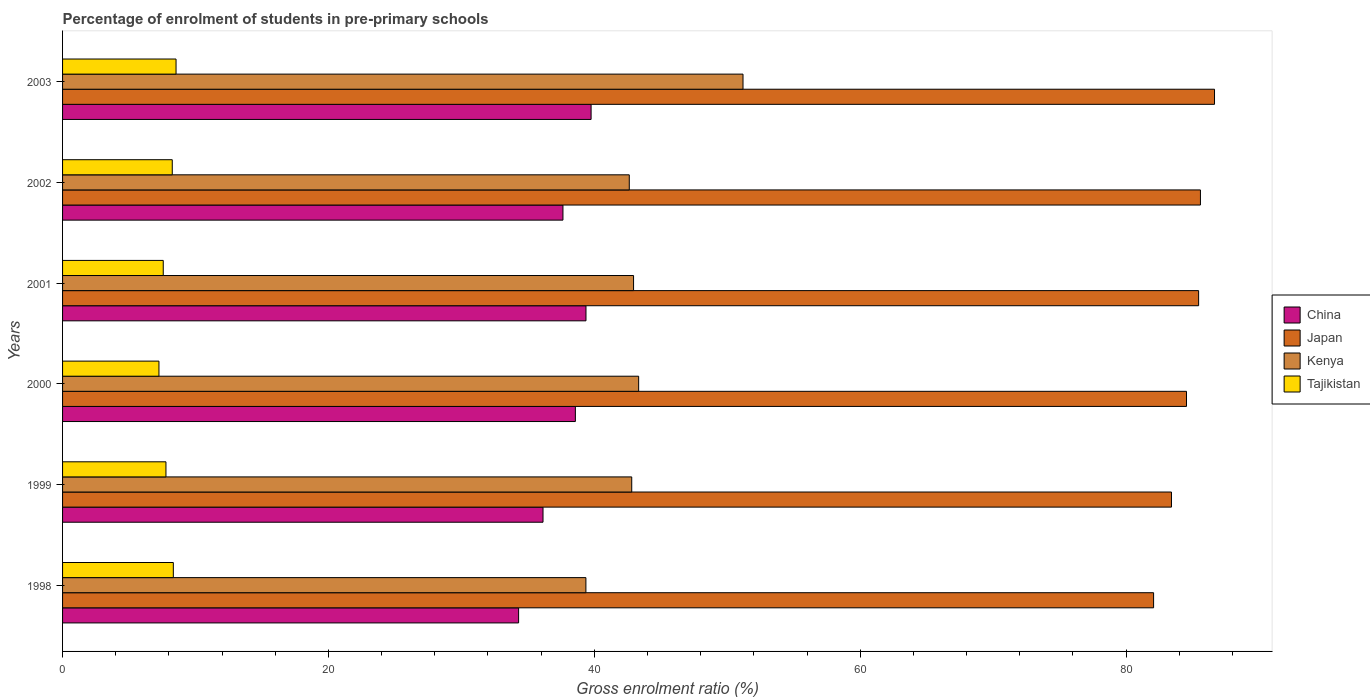Are the number of bars per tick equal to the number of legend labels?
Your response must be concise. Yes. How many bars are there on the 2nd tick from the top?
Offer a very short reply. 4. How many bars are there on the 5th tick from the bottom?
Ensure brevity in your answer.  4. What is the label of the 6th group of bars from the top?
Offer a very short reply. 1998. In how many cases, is the number of bars for a given year not equal to the number of legend labels?
Ensure brevity in your answer.  0. What is the percentage of students enrolled in pre-primary schools in Tajikistan in 2003?
Offer a terse response. 8.54. Across all years, what is the maximum percentage of students enrolled in pre-primary schools in Tajikistan?
Your response must be concise. 8.54. Across all years, what is the minimum percentage of students enrolled in pre-primary schools in Japan?
Keep it short and to the point. 82.07. What is the total percentage of students enrolled in pre-primary schools in Japan in the graph?
Offer a terse response. 507.73. What is the difference between the percentage of students enrolled in pre-primary schools in Kenya in 1999 and that in 2000?
Your answer should be compact. -0.52. What is the difference between the percentage of students enrolled in pre-primary schools in China in 2000 and the percentage of students enrolled in pre-primary schools in Tajikistan in 2001?
Provide a short and direct response. 31. What is the average percentage of students enrolled in pre-primary schools in Japan per year?
Offer a very short reply. 84.62. In the year 1999, what is the difference between the percentage of students enrolled in pre-primary schools in Tajikistan and percentage of students enrolled in pre-primary schools in China?
Provide a succinct answer. -28.36. What is the ratio of the percentage of students enrolled in pre-primary schools in Kenya in 1999 to that in 2002?
Provide a succinct answer. 1. Is the difference between the percentage of students enrolled in pre-primary schools in Tajikistan in 1999 and 2001 greater than the difference between the percentage of students enrolled in pre-primary schools in China in 1999 and 2001?
Make the answer very short. Yes. What is the difference between the highest and the second highest percentage of students enrolled in pre-primary schools in Kenya?
Keep it short and to the point. 7.85. What is the difference between the highest and the lowest percentage of students enrolled in pre-primary schools in Japan?
Your response must be concise. 4.58. Is it the case that in every year, the sum of the percentage of students enrolled in pre-primary schools in Japan and percentage of students enrolled in pre-primary schools in Tajikistan is greater than the sum of percentage of students enrolled in pre-primary schools in China and percentage of students enrolled in pre-primary schools in Kenya?
Offer a very short reply. Yes. What does the 4th bar from the top in 2002 represents?
Provide a short and direct response. China. What does the 3rd bar from the bottom in 2000 represents?
Provide a succinct answer. Kenya. Is it the case that in every year, the sum of the percentage of students enrolled in pre-primary schools in China and percentage of students enrolled in pre-primary schools in Tajikistan is greater than the percentage of students enrolled in pre-primary schools in Kenya?
Give a very brief answer. No. How many bars are there?
Offer a very short reply. 24. Are the values on the major ticks of X-axis written in scientific E-notation?
Offer a terse response. No. Does the graph contain any zero values?
Your answer should be very brief. No. Does the graph contain grids?
Provide a short and direct response. No. How are the legend labels stacked?
Ensure brevity in your answer.  Vertical. What is the title of the graph?
Make the answer very short. Percentage of enrolment of students in pre-primary schools. What is the Gross enrolment ratio (%) of China in 1998?
Make the answer very short. 34.31. What is the Gross enrolment ratio (%) in Japan in 1998?
Offer a terse response. 82.07. What is the Gross enrolment ratio (%) in Kenya in 1998?
Make the answer very short. 39.37. What is the Gross enrolment ratio (%) in Tajikistan in 1998?
Your answer should be compact. 8.33. What is the Gross enrolment ratio (%) of China in 1999?
Keep it short and to the point. 36.14. What is the Gross enrolment ratio (%) in Japan in 1999?
Give a very brief answer. 83.41. What is the Gross enrolment ratio (%) in Kenya in 1999?
Your response must be concise. 42.81. What is the Gross enrolment ratio (%) in Tajikistan in 1999?
Your response must be concise. 7.78. What is the Gross enrolment ratio (%) of China in 2000?
Offer a terse response. 38.57. What is the Gross enrolment ratio (%) in Japan in 2000?
Ensure brevity in your answer.  84.55. What is the Gross enrolment ratio (%) in Kenya in 2000?
Provide a short and direct response. 43.34. What is the Gross enrolment ratio (%) in Tajikistan in 2000?
Your answer should be very brief. 7.25. What is the Gross enrolment ratio (%) in China in 2001?
Ensure brevity in your answer.  39.37. What is the Gross enrolment ratio (%) in Japan in 2001?
Your response must be concise. 85.46. What is the Gross enrolment ratio (%) in Kenya in 2001?
Make the answer very short. 42.95. What is the Gross enrolment ratio (%) of Tajikistan in 2001?
Your answer should be very brief. 7.57. What is the Gross enrolment ratio (%) in China in 2002?
Offer a very short reply. 37.64. What is the Gross enrolment ratio (%) in Japan in 2002?
Keep it short and to the point. 85.59. What is the Gross enrolment ratio (%) of Kenya in 2002?
Your answer should be compact. 42.63. What is the Gross enrolment ratio (%) of Tajikistan in 2002?
Ensure brevity in your answer.  8.25. What is the Gross enrolment ratio (%) of China in 2003?
Your response must be concise. 39.76. What is the Gross enrolment ratio (%) in Japan in 2003?
Your response must be concise. 86.65. What is the Gross enrolment ratio (%) in Kenya in 2003?
Your answer should be very brief. 51.18. What is the Gross enrolment ratio (%) of Tajikistan in 2003?
Keep it short and to the point. 8.54. Across all years, what is the maximum Gross enrolment ratio (%) of China?
Provide a short and direct response. 39.76. Across all years, what is the maximum Gross enrolment ratio (%) in Japan?
Ensure brevity in your answer.  86.65. Across all years, what is the maximum Gross enrolment ratio (%) of Kenya?
Provide a short and direct response. 51.18. Across all years, what is the maximum Gross enrolment ratio (%) in Tajikistan?
Your response must be concise. 8.54. Across all years, what is the minimum Gross enrolment ratio (%) of China?
Keep it short and to the point. 34.31. Across all years, what is the minimum Gross enrolment ratio (%) of Japan?
Offer a terse response. 82.07. Across all years, what is the minimum Gross enrolment ratio (%) of Kenya?
Give a very brief answer. 39.37. Across all years, what is the minimum Gross enrolment ratio (%) of Tajikistan?
Give a very brief answer. 7.25. What is the total Gross enrolment ratio (%) in China in the graph?
Your response must be concise. 225.79. What is the total Gross enrolment ratio (%) in Japan in the graph?
Your answer should be compact. 507.73. What is the total Gross enrolment ratio (%) of Kenya in the graph?
Give a very brief answer. 262.29. What is the total Gross enrolment ratio (%) in Tajikistan in the graph?
Ensure brevity in your answer.  47.72. What is the difference between the Gross enrolment ratio (%) in China in 1998 and that in 1999?
Make the answer very short. -1.83. What is the difference between the Gross enrolment ratio (%) in Japan in 1998 and that in 1999?
Ensure brevity in your answer.  -1.34. What is the difference between the Gross enrolment ratio (%) in Kenya in 1998 and that in 1999?
Your response must be concise. -3.45. What is the difference between the Gross enrolment ratio (%) of Tajikistan in 1998 and that in 1999?
Ensure brevity in your answer.  0.55. What is the difference between the Gross enrolment ratio (%) in China in 1998 and that in 2000?
Offer a very short reply. -4.27. What is the difference between the Gross enrolment ratio (%) of Japan in 1998 and that in 2000?
Provide a short and direct response. -2.47. What is the difference between the Gross enrolment ratio (%) of Kenya in 1998 and that in 2000?
Offer a terse response. -3.97. What is the difference between the Gross enrolment ratio (%) of Tajikistan in 1998 and that in 2000?
Your answer should be very brief. 1.08. What is the difference between the Gross enrolment ratio (%) of China in 1998 and that in 2001?
Make the answer very short. -5.07. What is the difference between the Gross enrolment ratio (%) of Japan in 1998 and that in 2001?
Your response must be concise. -3.39. What is the difference between the Gross enrolment ratio (%) in Kenya in 1998 and that in 2001?
Ensure brevity in your answer.  -3.58. What is the difference between the Gross enrolment ratio (%) in Tajikistan in 1998 and that in 2001?
Ensure brevity in your answer.  0.76. What is the difference between the Gross enrolment ratio (%) in China in 1998 and that in 2002?
Your response must be concise. -3.33. What is the difference between the Gross enrolment ratio (%) in Japan in 1998 and that in 2002?
Keep it short and to the point. -3.52. What is the difference between the Gross enrolment ratio (%) of Kenya in 1998 and that in 2002?
Keep it short and to the point. -3.26. What is the difference between the Gross enrolment ratio (%) of Tajikistan in 1998 and that in 2002?
Offer a very short reply. 0.08. What is the difference between the Gross enrolment ratio (%) of China in 1998 and that in 2003?
Your response must be concise. -5.45. What is the difference between the Gross enrolment ratio (%) in Japan in 1998 and that in 2003?
Provide a succinct answer. -4.58. What is the difference between the Gross enrolment ratio (%) of Kenya in 1998 and that in 2003?
Give a very brief answer. -11.82. What is the difference between the Gross enrolment ratio (%) of Tajikistan in 1998 and that in 2003?
Give a very brief answer. -0.2. What is the difference between the Gross enrolment ratio (%) in China in 1999 and that in 2000?
Your answer should be compact. -2.43. What is the difference between the Gross enrolment ratio (%) of Japan in 1999 and that in 2000?
Offer a terse response. -1.13. What is the difference between the Gross enrolment ratio (%) in Kenya in 1999 and that in 2000?
Your answer should be very brief. -0.52. What is the difference between the Gross enrolment ratio (%) in Tajikistan in 1999 and that in 2000?
Provide a short and direct response. 0.53. What is the difference between the Gross enrolment ratio (%) in China in 1999 and that in 2001?
Ensure brevity in your answer.  -3.23. What is the difference between the Gross enrolment ratio (%) in Japan in 1999 and that in 2001?
Your answer should be very brief. -2.04. What is the difference between the Gross enrolment ratio (%) in Kenya in 1999 and that in 2001?
Offer a very short reply. -0.14. What is the difference between the Gross enrolment ratio (%) in Tajikistan in 1999 and that in 2001?
Provide a short and direct response. 0.2. What is the difference between the Gross enrolment ratio (%) in China in 1999 and that in 2002?
Make the answer very short. -1.5. What is the difference between the Gross enrolment ratio (%) in Japan in 1999 and that in 2002?
Keep it short and to the point. -2.18. What is the difference between the Gross enrolment ratio (%) in Kenya in 1999 and that in 2002?
Ensure brevity in your answer.  0.18. What is the difference between the Gross enrolment ratio (%) in Tajikistan in 1999 and that in 2002?
Offer a terse response. -0.47. What is the difference between the Gross enrolment ratio (%) of China in 1999 and that in 2003?
Your answer should be compact. -3.62. What is the difference between the Gross enrolment ratio (%) in Japan in 1999 and that in 2003?
Keep it short and to the point. -3.24. What is the difference between the Gross enrolment ratio (%) in Kenya in 1999 and that in 2003?
Provide a short and direct response. -8.37. What is the difference between the Gross enrolment ratio (%) of Tajikistan in 1999 and that in 2003?
Your answer should be compact. -0.76. What is the difference between the Gross enrolment ratio (%) in China in 2000 and that in 2001?
Provide a short and direct response. -0.8. What is the difference between the Gross enrolment ratio (%) in Japan in 2000 and that in 2001?
Your response must be concise. -0.91. What is the difference between the Gross enrolment ratio (%) in Kenya in 2000 and that in 2001?
Offer a very short reply. 0.38. What is the difference between the Gross enrolment ratio (%) in Tajikistan in 2000 and that in 2001?
Keep it short and to the point. -0.32. What is the difference between the Gross enrolment ratio (%) of China in 2000 and that in 2002?
Provide a short and direct response. 0.93. What is the difference between the Gross enrolment ratio (%) in Japan in 2000 and that in 2002?
Your answer should be compact. -1.05. What is the difference between the Gross enrolment ratio (%) of Kenya in 2000 and that in 2002?
Make the answer very short. 0.7. What is the difference between the Gross enrolment ratio (%) in Tajikistan in 2000 and that in 2002?
Make the answer very short. -1. What is the difference between the Gross enrolment ratio (%) in China in 2000 and that in 2003?
Give a very brief answer. -1.18. What is the difference between the Gross enrolment ratio (%) in Japan in 2000 and that in 2003?
Provide a short and direct response. -2.11. What is the difference between the Gross enrolment ratio (%) of Kenya in 2000 and that in 2003?
Your response must be concise. -7.85. What is the difference between the Gross enrolment ratio (%) of Tajikistan in 2000 and that in 2003?
Offer a terse response. -1.29. What is the difference between the Gross enrolment ratio (%) in China in 2001 and that in 2002?
Your answer should be very brief. 1.73. What is the difference between the Gross enrolment ratio (%) of Japan in 2001 and that in 2002?
Your answer should be compact. -0.14. What is the difference between the Gross enrolment ratio (%) in Kenya in 2001 and that in 2002?
Ensure brevity in your answer.  0.32. What is the difference between the Gross enrolment ratio (%) in Tajikistan in 2001 and that in 2002?
Offer a very short reply. -0.68. What is the difference between the Gross enrolment ratio (%) in China in 2001 and that in 2003?
Make the answer very short. -0.38. What is the difference between the Gross enrolment ratio (%) in Japan in 2001 and that in 2003?
Your answer should be very brief. -1.2. What is the difference between the Gross enrolment ratio (%) in Kenya in 2001 and that in 2003?
Offer a terse response. -8.23. What is the difference between the Gross enrolment ratio (%) in Tajikistan in 2001 and that in 2003?
Offer a very short reply. -0.96. What is the difference between the Gross enrolment ratio (%) in China in 2002 and that in 2003?
Make the answer very short. -2.12. What is the difference between the Gross enrolment ratio (%) in Japan in 2002 and that in 2003?
Make the answer very short. -1.06. What is the difference between the Gross enrolment ratio (%) of Kenya in 2002 and that in 2003?
Provide a succinct answer. -8.55. What is the difference between the Gross enrolment ratio (%) of Tajikistan in 2002 and that in 2003?
Provide a short and direct response. -0.28. What is the difference between the Gross enrolment ratio (%) of China in 1998 and the Gross enrolment ratio (%) of Japan in 1999?
Provide a short and direct response. -49.11. What is the difference between the Gross enrolment ratio (%) of China in 1998 and the Gross enrolment ratio (%) of Kenya in 1999?
Provide a succinct answer. -8.51. What is the difference between the Gross enrolment ratio (%) in China in 1998 and the Gross enrolment ratio (%) in Tajikistan in 1999?
Offer a very short reply. 26.53. What is the difference between the Gross enrolment ratio (%) in Japan in 1998 and the Gross enrolment ratio (%) in Kenya in 1999?
Your response must be concise. 39.26. What is the difference between the Gross enrolment ratio (%) of Japan in 1998 and the Gross enrolment ratio (%) of Tajikistan in 1999?
Offer a very short reply. 74.29. What is the difference between the Gross enrolment ratio (%) of Kenya in 1998 and the Gross enrolment ratio (%) of Tajikistan in 1999?
Your answer should be compact. 31.59. What is the difference between the Gross enrolment ratio (%) in China in 1998 and the Gross enrolment ratio (%) in Japan in 2000?
Your answer should be compact. -50.24. What is the difference between the Gross enrolment ratio (%) in China in 1998 and the Gross enrolment ratio (%) in Kenya in 2000?
Give a very brief answer. -9.03. What is the difference between the Gross enrolment ratio (%) in China in 1998 and the Gross enrolment ratio (%) in Tajikistan in 2000?
Provide a short and direct response. 27.05. What is the difference between the Gross enrolment ratio (%) in Japan in 1998 and the Gross enrolment ratio (%) in Kenya in 2000?
Offer a terse response. 38.73. What is the difference between the Gross enrolment ratio (%) of Japan in 1998 and the Gross enrolment ratio (%) of Tajikistan in 2000?
Ensure brevity in your answer.  74.82. What is the difference between the Gross enrolment ratio (%) of Kenya in 1998 and the Gross enrolment ratio (%) of Tajikistan in 2000?
Offer a very short reply. 32.12. What is the difference between the Gross enrolment ratio (%) of China in 1998 and the Gross enrolment ratio (%) of Japan in 2001?
Offer a very short reply. -51.15. What is the difference between the Gross enrolment ratio (%) of China in 1998 and the Gross enrolment ratio (%) of Kenya in 2001?
Provide a succinct answer. -8.65. What is the difference between the Gross enrolment ratio (%) in China in 1998 and the Gross enrolment ratio (%) in Tajikistan in 2001?
Offer a terse response. 26.73. What is the difference between the Gross enrolment ratio (%) of Japan in 1998 and the Gross enrolment ratio (%) of Kenya in 2001?
Give a very brief answer. 39.12. What is the difference between the Gross enrolment ratio (%) in Japan in 1998 and the Gross enrolment ratio (%) in Tajikistan in 2001?
Ensure brevity in your answer.  74.5. What is the difference between the Gross enrolment ratio (%) in Kenya in 1998 and the Gross enrolment ratio (%) in Tajikistan in 2001?
Offer a terse response. 31.79. What is the difference between the Gross enrolment ratio (%) of China in 1998 and the Gross enrolment ratio (%) of Japan in 2002?
Ensure brevity in your answer.  -51.29. What is the difference between the Gross enrolment ratio (%) of China in 1998 and the Gross enrolment ratio (%) of Kenya in 2002?
Offer a terse response. -8.32. What is the difference between the Gross enrolment ratio (%) of China in 1998 and the Gross enrolment ratio (%) of Tajikistan in 2002?
Offer a very short reply. 26.05. What is the difference between the Gross enrolment ratio (%) of Japan in 1998 and the Gross enrolment ratio (%) of Kenya in 2002?
Provide a short and direct response. 39.44. What is the difference between the Gross enrolment ratio (%) in Japan in 1998 and the Gross enrolment ratio (%) in Tajikistan in 2002?
Ensure brevity in your answer.  73.82. What is the difference between the Gross enrolment ratio (%) of Kenya in 1998 and the Gross enrolment ratio (%) of Tajikistan in 2002?
Make the answer very short. 31.12. What is the difference between the Gross enrolment ratio (%) of China in 1998 and the Gross enrolment ratio (%) of Japan in 2003?
Offer a terse response. -52.35. What is the difference between the Gross enrolment ratio (%) of China in 1998 and the Gross enrolment ratio (%) of Kenya in 2003?
Ensure brevity in your answer.  -16.88. What is the difference between the Gross enrolment ratio (%) of China in 1998 and the Gross enrolment ratio (%) of Tajikistan in 2003?
Your answer should be compact. 25.77. What is the difference between the Gross enrolment ratio (%) of Japan in 1998 and the Gross enrolment ratio (%) of Kenya in 2003?
Ensure brevity in your answer.  30.89. What is the difference between the Gross enrolment ratio (%) of Japan in 1998 and the Gross enrolment ratio (%) of Tajikistan in 2003?
Provide a short and direct response. 73.53. What is the difference between the Gross enrolment ratio (%) in Kenya in 1998 and the Gross enrolment ratio (%) in Tajikistan in 2003?
Your response must be concise. 30.83. What is the difference between the Gross enrolment ratio (%) in China in 1999 and the Gross enrolment ratio (%) in Japan in 2000?
Keep it short and to the point. -48.4. What is the difference between the Gross enrolment ratio (%) in China in 1999 and the Gross enrolment ratio (%) in Kenya in 2000?
Provide a succinct answer. -7.2. What is the difference between the Gross enrolment ratio (%) of China in 1999 and the Gross enrolment ratio (%) of Tajikistan in 2000?
Your response must be concise. 28.89. What is the difference between the Gross enrolment ratio (%) in Japan in 1999 and the Gross enrolment ratio (%) in Kenya in 2000?
Your answer should be very brief. 40.08. What is the difference between the Gross enrolment ratio (%) in Japan in 1999 and the Gross enrolment ratio (%) in Tajikistan in 2000?
Make the answer very short. 76.16. What is the difference between the Gross enrolment ratio (%) of Kenya in 1999 and the Gross enrolment ratio (%) of Tajikistan in 2000?
Provide a short and direct response. 35.56. What is the difference between the Gross enrolment ratio (%) of China in 1999 and the Gross enrolment ratio (%) of Japan in 2001?
Your answer should be very brief. -49.32. What is the difference between the Gross enrolment ratio (%) of China in 1999 and the Gross enrolment ratio (%) of Kenya in 2001?
Give a very brief answer. -6.81. What is the difference between the Gross enrolment ratio (%) in China in 1999 and the Gross enrolment ratio (%) in Tajikistan in 2001?
Your answer should be compact. 28.57. What is the difference between the Gross enrolment ratio (%) of Japan in 1999 and the Gross enrolment ratio (%) of Kenya in 2001?
Offer a very short reply. 40.46. What is the difference between the Gross enrolment ratio (%) of Japan in 1999 and the Gross enrolment ratio (%) of Tajikistan in 2001?
Provide a succinct answer. 75.84. What is the difference between the Gross enrolment ratio (%) of Kenya in 1999 and the Gross enrolment ratio (%) of Tajikistan in 2001?
Offer a very short reply. 35.24. What is the difference between the Gross enrolment ratio (%) in China in 1999 and the Gross enrolment ratio (%) in Japan in 2002?
Offer a very short reply. -49.45. What is the difference between the Gross enrolment ratio (%) in China in 1999 and the Gross enrolment ratio (%) in Kenya in 2002?
Your answer should be very brief. -6.49. What is the difference between the Gross enrolment ratio (%) in China in 1999 and the Gross enrolment ratio (%) in Tajikistan in 2002?
Offer a terse response. 27.89. What is the difference between the Gross enrolment ratio (%) of Japan in 1999 and the Gross enrolment ratio (%) of Kenya in 2002?
Your answer should be compact. 40.78. What is the difference between the Gross enrolment ratio (%) in Japan in 1999 and the Gross enrolment ratio (%) in Tajikistan in 2002?
Your answer should be compact. 75.16. What is the difference between the Gross enrolment ratio (%) of Kenya in 1999 and the Gross enrolment ratio (%) of Tajikistan in 2002?
Provide a short and direct response. 34.56. What is the difference between the Gross enrolment ratio (%) in China in 1999 and the Gross enrolment ratio (%) in Japan in 2003?
Provide a succinct answer. -50.51. What is the difference between the Gross enrolment ratio (%) of China in 1999 and the Gross enrolment ratio (%) of Kenya in 2003?
Ensure brevity in your answer.  -15.04. What is the difference between the Gross enrolment ratio (%) of China in 1999 and the Gross enrolment ratio (%) of Tajikistan in 2003?
Make the answer very short. 27.6. What is the difference between the Gross enrolment ratio (%) in Japan in 1999 and the Gross enrolment ratio (%) in Kenya in 2003?
Keep it short and to the point. 32.23. What is the difference between the Gross enrolment ratio (%) of Japan in 1999 and the Gross enrolment ratio (%) of Tajikistan in 2003?
Make the answer very short. 74.88. What is the difference between the Gross enrolment ratio (%) of Kenya in 1999 and the Gross enrolment ratio (%) of Tajikistan in 2003?
Your answer should be compact. 34.28. What is the difference between the Gross enrolment ratio (%) of China in 2000 and the Gross enrolment ratio (%) of Japan in 2001?
Ensure brevity in your answer.  -46.88. What is the difference between the Gross enrolment ratio (%) of China in 2000 and the Gross enrolment ratio (%) of Kenya in 2001?
Offer a terse response. -4.38. What is the difference between the Gross enrolment ratio (%) of China in 2000 and the Gross enrolment ratio (%) of Tajikistan in 2001?
Your response must be concise. 31. What is the difference between the Gross enrolment ratio (%) in Japan in 2000 and the Gross enrolment ratio (%) in Kenya in 2001?
Provide a succinct answer. 41.59. What is the difference between the Gross enrolment ratio (%) of Japan in 2000 and the Gross enrolment ratio (%) of Tajikistan in 2001?
Keep it short and to the point. 76.97. What is the difference between the Gross enrolment ratio (%) of Kenya in 2000 and the Gross enrolment ratio (%) of Tajikistan in 2001?
Keep it short and to the point. 35.76. What is the difference between the Gross enrolment ratio (%) of China in 2000 and the Gross enrolment ratio (%) of Japan in 2002?
Provide a short and direct response. -47.02. What is the difference between the Gross enrolment ratio (%) of China in 2000 and the Gross enrolment ratio (%) of Kenya in 2002?
Your answer should be compact. -4.06. What is the difference between the Gross enrolment ratio (%) in China in 2000 and the Gross enrolment ratio (%) in Tajikistan in 2002?
Provide a short and direct response. 30.32. What is the difference between the Gross enrolment ratio (%) in Japan in 2000 and the Gross enrolment ratio (%) in Kenya in 2002?
Provide a succinct answer. 41.91. What is the difference between the Gross enrolment ratio (%) of Japan in 2000 and the Gross enrolment ratio (%) of Tajikistan in 2002?
Your answer should be very brief. 76.29. What is the difference between the Gross enrolment ratio (%) of Kenya in 2000 and the Gross enrolment ratio (%) of Tajikistan in 2002?
Offer a terse response. 35.08. What is the difference between the Gross enrolment ratio (%) of China in 2000 and the Gross enrolment ratio (%) of Japan in 2003?
Your response must be concise. -48.08. What is the difference between the Gross enrolment ratio (%) of China in 2000 and the Gross enrolment ratio (%) of Kenya in 2003?
Provide a short and direct response. -12.61. What is the difference between the Gross enrolment ratio (%) in China in 2000 and the Gross enrolment ratio (%) in Tajikistan in 2003?
Provide a short and direct response. 30.04. What is the difference between the Gross enrolment ratio (%) of Japan in 2000 and the Gross enrolment ratio (%) of Kenya in 2003?
Keep it short and to the point. 33.36. What is the difference between the Gross enrolment ratio (%) of Japan in 2000 and the Gross enrolment ratio (%) of Tajikistan in 2003?
Make the answer very short. 76.01. What is the difference between the Gross enrolment ratio (%) in Kenya in 2000 and the Gross enrolment ratio (%) in Tajikistan in 2003?
Provide a succinct answer. 34.8. What is the difference between the Gross enrolment ratio (%) in China in 2001 and the Gross enrolment ratio (%) in Japan in 2002?
Provide a short and direct response. -46.22. What is the difference between the Gross enrolment ratio (%) of China in 2001 and the Gross enrolment ratio (%) of Kenya in 2002?
Provide a short and direct response. -3.26. What is the difference between the Gross enrolment ratio (%) of China in 2001 and the Gross enrolment ratio (%) of Tajikistan in 2002?
Keep it short and to the point. 31.12. What is the difference between the Gross enrolment ratio (%) of Japan in 2001 and the Gross enrolment ratio (%) of Kenya in 2002?
Keep it short and to the point. 42.83. What is the difference between the Gross enrolment ratio (%) of Japan in 2001 and the Gross enrolment ratio (%) of Tajikistan in 2002?
Ensure brevity in your answer.  77.21. What is the difference between the Gross enrolment ratio (%) of Kenya in 2001 and the Gross enrolment ratio (%) of Tajikistan in 2002?
Offer a terse response. 34.7. What is the difference between the Gross enrolment ratio (%) of China in 2001 and the Gross enrolment ratio (%) of Japan in 2003?
Provide a succinct answer. -47.28. What is the difference between the Gross enrolment ratio (%) of China in 2001 and the Gross enrolment ratio (%) of Kenya in 2003?
Make the answer very short. -11.81. What is the difference between the Gross enrolment ratio (%) in China in 2001 and the Gross enrolment ratio (%) in Tajikistan in 2003?
Your answer should be very brief. 30.84. What is the difference between the Gross enrolment ratio (%) in Japan in 2001 and the Gross enrolment ratio (%) in Kenya in 2003?
Offer a terse response. 34.27. What is the difference between the Gross enrolment ratio (%) in Japan in 2001 and the Gross enrolment ratio (%) in Tajikistan in 2003?
Offer a terse response. 76.92. What is the difference between the Gross enrolment ratio (%) of Kenya in 2001 and the Gross enrolment ratio (%) of Tajikistan in 2003?
Keep it short and to the point. 34.42. What is the difference between the Gross enrolment ratio (%) of China in 2002 and the Gross enrolment ratio (%) of Japan in 2003?
Make the answer very short. -49.01. What is the difference between the Gross enrolment ratio (%) of China in 2002 and the Gross enrolment ratio (%) of Kenya in 2003?
Offer a terse response. -13.54. What is the difference between the Gross enrolment ratio (%) in China in 2002 and the Gross enrolment ratio (%) in Tajikistan in 2003?
Keep it short and to the point. 29.1. What is the difference between the Gross enrolment ratio (%) in Japan in 2002 and the Gross enrolment ratio (%) in Kenya in 2003?
Offer a terse response. 34.41. What is the difference between the Gross enrolment ratio (%) of Japan in 2002 and the Gross enrolment ratio (%) of Tajikistan in 2003?
Give a very brief answer. 77.06. What is the difference between the Gross enrolment ratio (%) in Kenya in 2002 and the Gross enrolment ratio (%) in Tajikistan in 2003?
Make the answer very short. 34.09. What is the average Gross enrolment ratio (%) in China per year?
Make the answer very short. 37.63. What is the average Gross enrolment ratio (%) in Japan per year?
Provide a short and direct response. 84.62. What is the average Gross enrolment ratio (%) of Kenya per year?
Ensure brevity in your answer.  43.71. What is the average Gross enrolment ratio (%) in Tajikistan per year?
Make the answer very short. 7.95. In the year 1998, what is the difference between the Gross enrolment ratio (%) of China and Gross enrolment ratio (%) of Japan?
Your response must be concise. -47.76. In the year 1998, what is the difference between the Gross enrolment ratio (%) of China and Gross enrolment ratio (%) of Kenya?
Your answer should be very brief. -5.06. In the year 1998, what is the difference between the Gross enrolment ratio (%) in China and Gross enrolment ratio (%) in Tajikistan?
Offer a terse response. 25.97. In the year 1998, what is the difference between the Gross enrolment ratio (%) in Japan and Gross enrolment ratio (%) in Kenya?
Make the answer very short. 42.7. In the year 1998, what is the difference between the Gross enrolment ratio (%) of Japan and Gross enrolment ratio (%) of Tajikistan?
Your response must be concise. 73.74. In the year 1998, what is the difference between the Gross enrolment ratio (%) in Kenya and Gross enrolment ratio (%) in Tajikistan?
Your answer should be very brief. 31.04. In the year 1999, what is the difference between the Gross enrolment ratio (%) of China and Gross enrolment ratio (%) of Japan?
Provide a short and direct response. -47.27. In the year 1999, what is the difference between the Gross enrolment ratio (%) of China and Gross enrolment ratio (%) of Kenya?
Give a very brief answer. -6.67. In the year 1999, what is the difference between the Gross enrolment ratio (%) of China and Gross enrolment ratio (%) of Tajikistan?
Give a very brief answer. 28.36. In the year 1999, what is the difference between the Gross enrolment ratio (%) of Japan and Gross enrolment ratio (%) of Kenya?
Your response must be concise. 40.6. In the year 1999, what is the difference between the Gross enrolment ratio (%) in Japan and Gross enrolment ratio (%) in Tajikistan?
Keep it short and to the point. 75.64. In the year 1999, what is the difference between the Gross enrolment ratio (%) in Kenya and Gross enrolment ratio (%) in Tajikistan?
Offer a very short reply. 35.04. In the year 2000, what is the difference between the Gross enrolment ratio (%) of China and Gross enrolment ratio (%) of Japan?
Offer a very short reply. -45.97. In the year 2000, what is the difference between the Gross enrolment ratio (%) in China and Gross enrolment ratio (%) in Kenya?
Give a very brief answer. -4.76. In the year 2000, what is the difference between the Gross enrolment ratio (%) of China and Gross enrolment ratio (%) of Tajikistan?
Make the answer very short. 31.32. In the year 2000, what is the difference between the Gross enrolment ratio (%) of Japan and Gross enrolment ratio (%) of Kenya?
Keep it short and to the point. 41.21. In the year 2000, what is the difference between the Gross enrolment ratio (%) in Japan and Gross enrolment ratio (%) in Tajikistan?
Provide a succinct answer. 77.29. In the year 2000, what is the difference between the Gross enrolment ratio (%) of Kenya and Gross enrolment ratio (%) of Tajikistan?
Your response must be concise. 36.08. In the year 2001, what is the difference between the Gross enrolment ratio (%) in China and Gross enrolment ratio (%) in Japan?
Your answer should be compact. -46.08. In the year 2001, what is the difference between the Gross enrolment ratio (%) of China and Gross enrolment ratio (%) of Kenya?
Ensure brevity in your answer.  -3.58. In the year 2001, what is the difference between the Gross enrolment ratio (%) of China and Gross enrolment ratio (%) of Tajikistan?
Provide a succinct answer. 31.8. In the year 2001, what is the difference between the Gross enrolment ratio (%) of Japan and Gross enrolment ratio (%) of Kenya?
Offer a terse response. 42.5. In the year 2001, what is the difference between the Gross enrolment ratio (%) in Japan and Gross enrolment ratio (%) in Tajikistan?
Your answer should be compact. 77.88. In the year 2001, what is the difference between the Gross enrolment ratio (%) of Kenya and Gross enrolment ratio (%) of Tajikistan?
Your response must be concise. 35.38. In the year 2002, what is the difference between the Gross enrolment ratio (%) in China and Gross enrolment ratio (%) in Japan?
Give a very brief answer. -47.95. In the year 2002, what is the difference between the Gross enrolment ratio (%) in China and Gross enrolment ratio (%) in Kenya?
Your response must be concise. -4.99. In the year 2002, what is the difference between the Gross enrolment ratio (%) of China and Gross enrolment ratio (%) of Tajikistan?
Keep it short and to the point. 29.39. In the year 2002, what is the difference between the Gross enrolment ratio (%) in Japan and Gross enrolment ratio (%) in Kenya?
Your response must be concise. 42.96. In the year 2002, what is the difference between the Gross enrolment ratio (%) in Japan and Gross enrolment ratio (%) in Tajikistan?
Give a very brief answer. 77.34. In the year 2002, what is the difference between the Gross enrolment ratio (%) of Kenya and Gross enrolment ratio (%) of Tajikistan?
Your answer should be compact. 34.38. In the year 2003, what is the difference between the Gross enrolment ratio (%) of China and Gross enrolment ratio (%) of Japan?
Provide a succinct answer. -46.9. In the year 2003, what is the difference between the Gross enrolment ratio (%) in China and Gross enrolment ratio (%) in Kenya?
Make the answer very short. -11.43. In the year 2003, what is the difference between the Gross enrolment ratio (%) of China and Gross enrolment ratio (%) of Tajikistan?
Provide a short and direct response. 31.22. In the year 2003, what is the difference between the Gross enrolment ratio (%) of Japan and Gross enrolment ratio (%) of Kenya?
Make the answer very short. 35.47. In the year 2003, what is the difference between the Gross enrolment ratio (%) in Japan and Gross enrolment ratio (%) in Tajikistan?
Your answer should be compact. 78.12. In the year 2003, what is the difference between the Gross enrolment ratio (%) in Kenya and Gross enrolment ratio (%) in Tajikistan?
Provide a short and direct response. 42.65. What is the ratio of the Gross enrolment ratio (%) in China in 1998 to that in 1999?
Your response must be concise. 0.95. What is the ratio of the Gross enrolment ratio (%) of Japan in 1998 to that in 1999?
Offer a very short reply. 0.98. What is the ratio of the Gross enrolment ratio (%) of Kenya in 1998 to that in 1999?
Make the answer very short. 0.92. What is the ratio of the Gross enrolment ratio (%) in Tajikistan in 1998 to that in 1999?
Offer a terse response. 1.07. What is the ratio of the Gross enrolment ratio (%) of China in 1998 to that in 2000?
Give a very brief answer. 0.89. What is the ratio of the Gross enrolment ratio (%) in Japan in 1998 to that in 2000?
Your response must be concise. 0.97. What is the ratio of the Gross enrolment ratio (%) of Kenya in 1998 to that in 2000?
Give a very brief answer. 0.91. What is the ratio of the Gross enrolment ratio (%) in Tajikistan in 1998 to that in 2000?
Your answer should be very brief. 1.15. What is the ratio of the Gross enrolment ratio (%) of China in 1998 to that in 2001?
Offer a terse response. 0.87. What is the ratio of the Gross enrolment ratio (%) of Japan in 1998 to that in 2001?
Offer a very short reply. 0.96. What is the ratio of the Gross enrolment ratio (%) in Kenya in 1998 to that in 2001?
Give a very brief answer. 0.92. What is the ratio of the Gross enrolment ratio (%) in Tajikistan in 1998 to that in 2001?
Provide a succinct answer. 1.1. What is the ratio of the Gross enrolment ratio (%) of China in 1998 to that in 2002?
Provide a short and direct response. 0.91. What is the ratio of the Gross enrolment ratio (%) in Japan in 1998 to that in 2002?
Provide a succinct answer. 0.96. What is the ratio of the Gross enrolment ratio (%) in Kenya in 1998 to that in 2002?
Offer a very short reply. 0.92. What is the ratio of the Gross enrolment ratio (%) of Tajikistan in 1998 to that in 2002?
Provide a short and direct response. 1.01. What is the ratio of the Gross enrolment ratio (%) of China in 1998 to that in 2003?
Keep it short and to the point. 0.86. What is the ratio of the Gross enrolment ratio (%) in Japan in 1998 to that in 2003?
Give a very brief answer. 0.95. What is the ratio of the Gross enrolment ratio (%) in Kenya in 1998 to that in 2003?
Ensure brevity in your answer.  0.77. What is the ratio of the Gross enrolment ratio (%) in China in 1999 to that in 2000?
Provide a succinct answer. 0.94. What is the ratio of the Gross enrolment ratio (%) of Japan in 1999 to that in 2000?
Offer a very short reply. 0.99. What is the ratio of the Gross enrolment ratio (%) of Tajikistan in 1999 to that in 2000?
Your answer should be compact. 1.07. What is the ratio of the Gross enrolment ratio (%) in China in 1999 to that in 2001?
Offer a very short reply. 0.92. What is the ratio of the Gross enrolment ratio (%) of Japan in 1999 to that in 2001?
Give a very brief answer. 0.98. What is the ratio of the Gross enrolment ratio (%) in Tajikistan in 1999 to that in 2001?
Your answer should be very brief. 1.03. What is the ratio of the Gross enrolment ratio (%) of China in 1999 to that in 2002?
Your answer should be very brief. 0.96. What is the ratio of the Gross enrolment ratio (%) in Japan in 1999 to that in 2002?
Provide a succinct answer. 0.97. What is the ratio of the Gross enrolment ratio (%) of Tajikistan in 1999 to that in 2002?
Give a very brief answer. 0.94. What is the ratio of the Gross enrolment ratio (%) in China in 1999 to that in 2003?
Provide a succinct answer. 0.91. What is the ratio of the Gross enrolment ratio (%) in Japan in 1999 to that in 2003?
Your answer should be compact. 0.96. What is the ratio of the Gross enrolment ratio (%) of Kenya in 1999 to that in 2003?
Your answer should be compact. 0.84. What is the ratio of the Gross enrolment ratio (%) of Tajikistan in 1999 to that in 2003?
Your answer should be compact. 0.91. What is the ratio of the Gross enrolment ratio (%) of China in 2000 to that in 2001?
Your answer should be compact. 0.98. What is the ratio of the Gross enrolment ratio (%) in Japan in 2000 to that in 2001?
Your answer should be very brief. 0.99. What is the ratio of the Gross enrolment ratio (%) of Kenya in 2000 to that in 2001?
Your answer should be very brief. 1.01. What is the ratio of the Gross enrolment ratio (%) of Tajikistan in 2000 to that in 2001?
Make the answer very short. 0.96. What is the ratio of the Gross enrolment ratio (%) of China in 2000 to that in 2002?
Keep it short and to the point. 1.02. What is the ratio of the Gross enrolment ratio (%) in Japan in 2000 to that in 2002?
Offer a very short reply. 0.99. What is the ratio of the Gross enrolment ratio (%) of Kenya in 2000 to that in 2002?
Ensure brevity in your answer.  1.02. What is the ratio of the Gross enrolment ratio (%) of Tajikistan in 2000 to that in 2002?
Make the answer very short. 0.88. What is the ratio of the Gross enrolment ratio (%) in China in 2000 to that in 2003?
Provide a succinct answer. 0.97. What is the ratio of the Gross enrolment ratio (%) of Japan in 2000 to that in 2003?
Provide a succinct answer. 0.98. What is the ratio of the Gross enrolment ratio (%) in Kenya in 2000 to that in 2003?
Your answer should be very brief. 0.85. What is the ratio of the Gross enrolment ratio (%) of Tajikistan in 2000 to that in 2003?
Offer a very short reply. 0.85. What is the ratio of the Gross enrolment ratio (%) in China in 2001 to that in 2002?
Provide a succinct answer. 1.05. What is the ratio of the Gross enrolment ratio (%) in Japan in 2001 to that in 2002?
Offer a very short reply. 1. What is the ratio of the Gross enrolment ratio (%) of Kenya in 2001 to that in 2002?
Your answer should be very brief. 1.01. What is the ratio of the Gross enrolment ratio (%) of Tajikistan in 2001 to that in 2002?
Offer a terse response. 0.92. What is the ratio of the Gross enrolment ratio (%) of China in 2001 to that in 2003?
Your answer should be compact. 0.99. What is the ratio of the Gross enrolment ratio (%) of Japan in 2001 to that in 2003?
Keep it short and to the point. 0.99. What is the ratio of the Gross enrolment ratio (%) in Kenya in 2001 to that in 2003?
Provide a succinct answer. 0.84. What is the ratio of the Gross enrolment ratio (%) of Tajikistan in 2001 to that in 2003?
Your answer should be very brief. 0.89. What is the ratio of the Gross enrolment ratio (%) of China in 2002 to that in 2003?
Provide a short and direct response. 0.95. What is the ratio of the Gross enrolment ratio (%) in Japan in 2002 to that in 2003?
Keep it short and to the point. 0.99. What is the ratio of the Gross enrolment ratio (%) in Kenya in 2002 to that in 2003?
Keep it short and to the point. 0.83. What is the ratio of the Gross enrolment ratio (%) of Tajikistan in 2002 to that in 2003?
Your answer should be very brief. 0.97. What is the difference between the highest and the second highest Gross enrolment ratio (%) of China?
Provide a succinct answer. 0.38. What is the difference between the highest and the second highest Gross enrolment ratio (%) in Japan?
Give a very brief answer. 1.06. What is the difference between the highest and the second highest Gross enrolment ratio (%) in Kenya?
Keep it short and to the point. 7.85. What is the difference between the highest and the second highest Gross enrolment ratio (%) in Tajikistan?
Your answer should be very brief. 0.2. What is the difference between the highest and the lowest Gross enrolment ratio (%) in China?
Keep it short and to the point. 5.45. What is the difference between the highest and the lowest Gross enrolment ratio (%) in Japan?
Provide a succinct answer. 4.58. What is the difference between the highest and the lowest Gross enrolment ratio (%) in Kenya?
Ensure brevity in your answer.  11.82. What is the difference between the highest and the lowest Gross enrolment ratio (%) in Tajikistan?
Your answer should be compact. 1.29. 